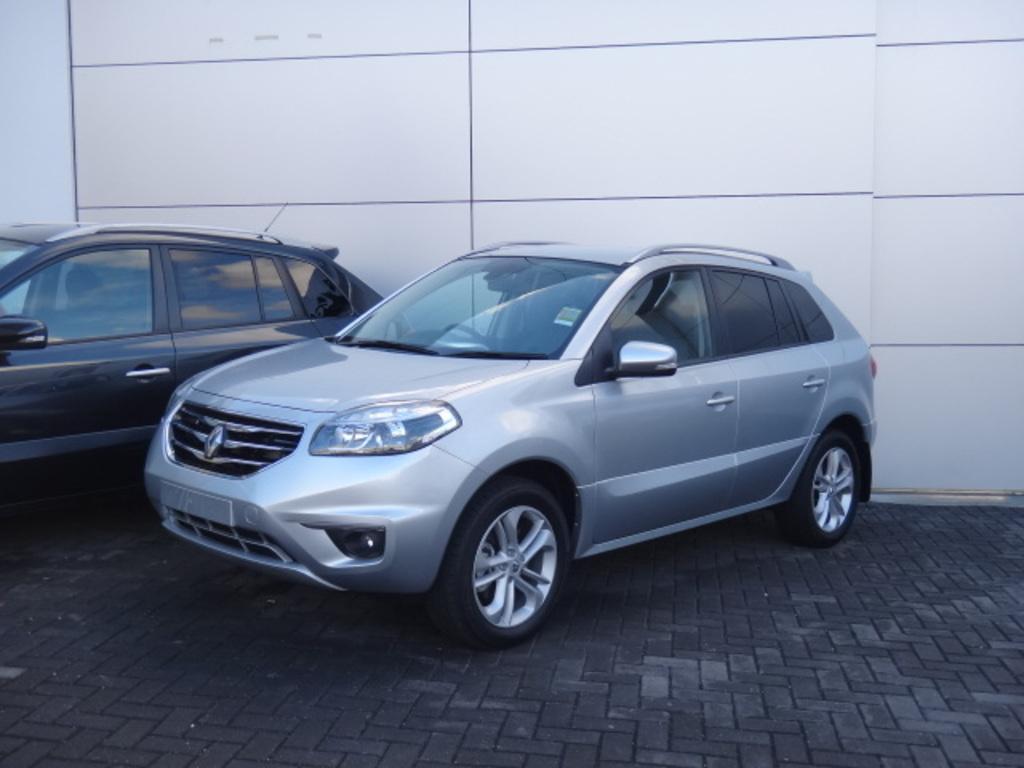Describe this image in one or two sentences. In this picture we can see 2 cars parked on the black floor in front of a white wall. 